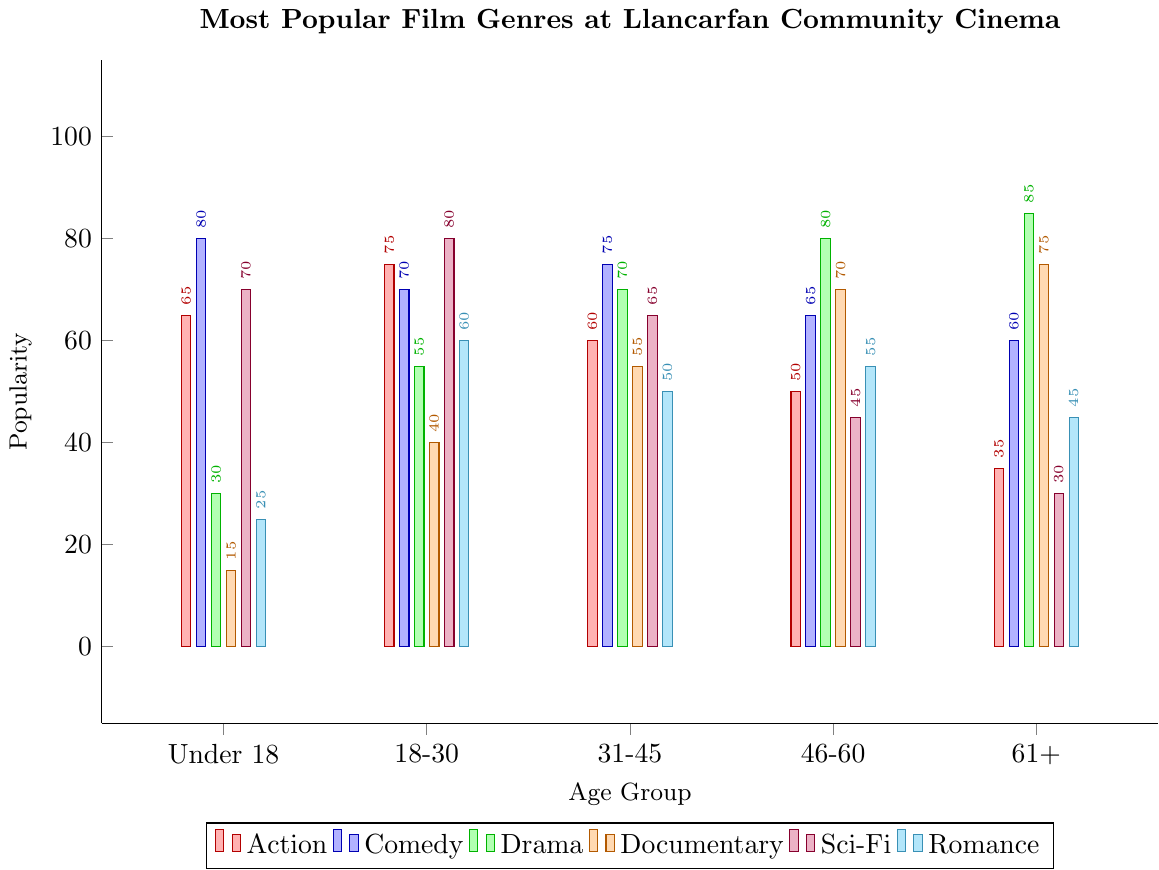Which age group finds Drama most popular? The height of the green bar indicates Drama preference across age groups. The tallest green bar is for the 61+ age group.
Answer: 61+ Which genre is most preferred by the 18-30 age group? Among the 18-30 age group, the tallest bar is the purple one, representing Sci-Fi, indicating the highest preference.
Answer: Sci-Fi Compare the popularity of Comedy and Romance for the Under 18 age group. Which one is higher? For the Under 18 group, the height of the blue bar (Comedy) is 80, and the height of the cyan bar (Romance) is 25. Comedy is higher.
Answer: Comedy What is the average popularity of Action across all age groups? Sum the Action values across all age groups (65 + 75 + 60 + 50 + 35) to get 285. Divide by the number of age groups (5). 285/5 = 57.
Answer: 57 How does the popularity of Documentaries change with age? Documentaries (orange bars) increase steadily from 15 for Under 18 to 75 for 61+, showing an upward trend as age increases.
Answer: Increases with age Which two genres have the closest popularity for the 46-60 age group? For the 46-60 group, compare the heights of all bars: Action (50), Comedy (65), Drama (80), Documentary (70), Sci-Fi (45), Romance (55). Romance and Action are closest with values 55 and 50, respectively.
Answer: Romance and Action For the 31-45 age group, what is the difference in popularity between Drama and Sci-Fi? For the 31-45 group, Drama is 70 and Sci-Fi is 65. The difference is 70 - 65 = 5.
Answer: 5 Which age group has the least interest in Sci-Fi? Look at the purple bars representing Sci-Fi. The shortest purple bar is in the 61+ age group.
Answer: 61+ Which genre shows a decline in popularity as age increases? Examine each genre's bars across age groups. Sci-Fi (purple bars) decreases steadily from Under 18 (70) to 61+ (30).
Answer: Sci-Fi What is the sum of the popularity scores for Romance across all age groups? Sum the Romance values across all age groups: (25 + 60 + 50 + 55 + 45) = 235.
Answer: 235 